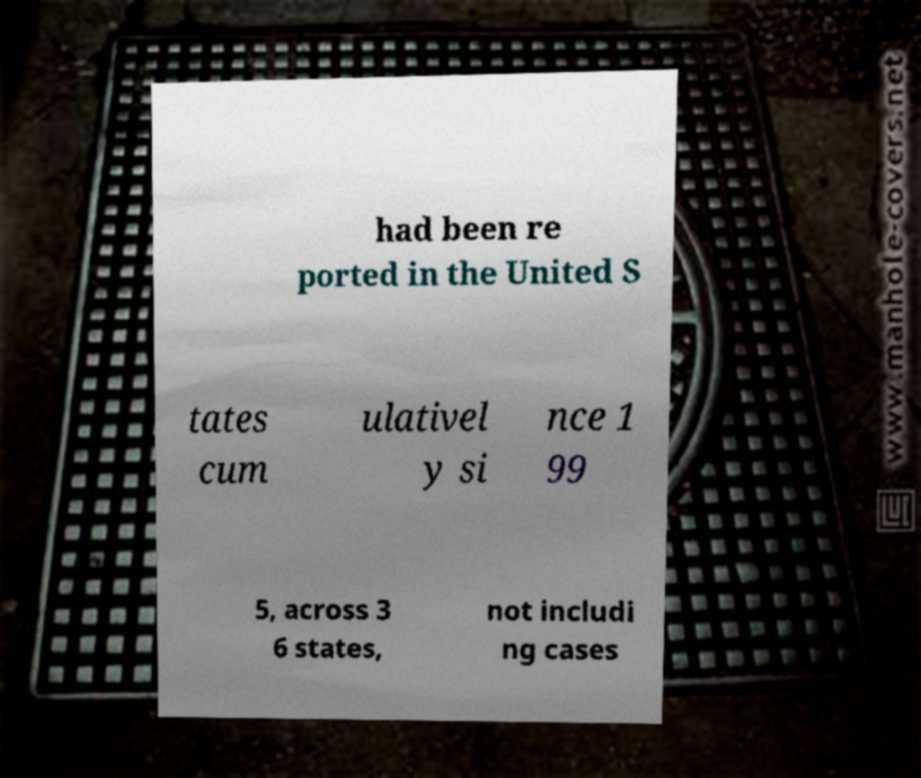There's text embedded in this image that I need extracted. Can you transcribe it verbatim? had been re ported in the United S tates cum ulativel y si nce 1 99 5, across 3 6 states, not includi ng cases 